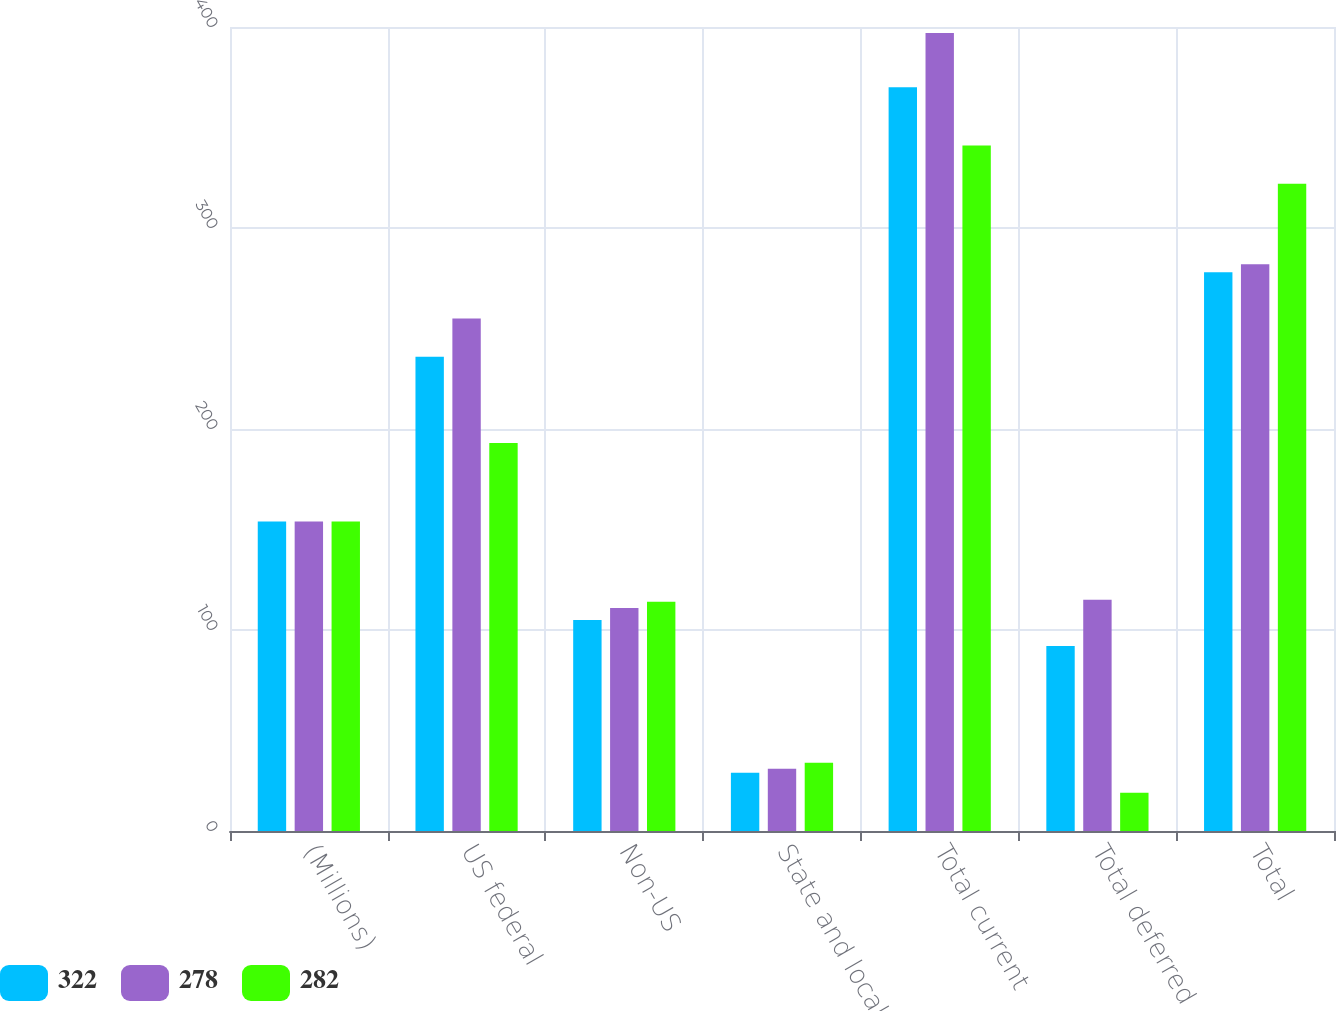Convert chart to OTSL. <chart><loc_0><loc_0><loc_500><loc_500><stacked_bar_chart><ecel><fcel>(Millions)<fcel>US federal<fcel>Non-US<fcel>State and local - US<fcel>Total current<fcel>Total deferred<fcel>Total<nl><fcel>322<fcel>154<fcel>236<fcel>105<fcel>29<fcel>370<fcel>92<fcel>278<nl><fcel>278<fcel>154<fcel>255<fcel>111<fcel>31<fcel>397<fcel>115<fcel>282<nl><fcel>282<fcel>154<fcel>193<fcel>114<fcel>34<fcel>341<fcel>19<fcel>322<nl></chart> 